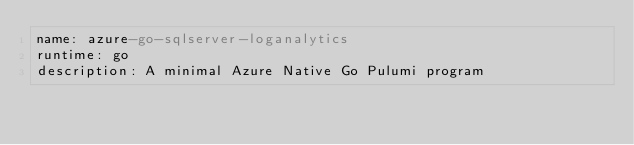Convert code to text. <code><loc_0><loc_0><loc_500><loc_500><_YAML_>name: azure-go-sqlserver-loganalytics
runtime: go
description: A minimal Azure Native Go Pulumi program
</code> 